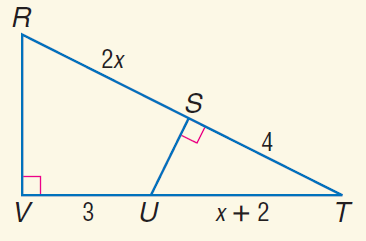Question: Find x.
Choices:
A. 3
B. 4
C. 5
D. 6
Answer with the letter. Answer: A 